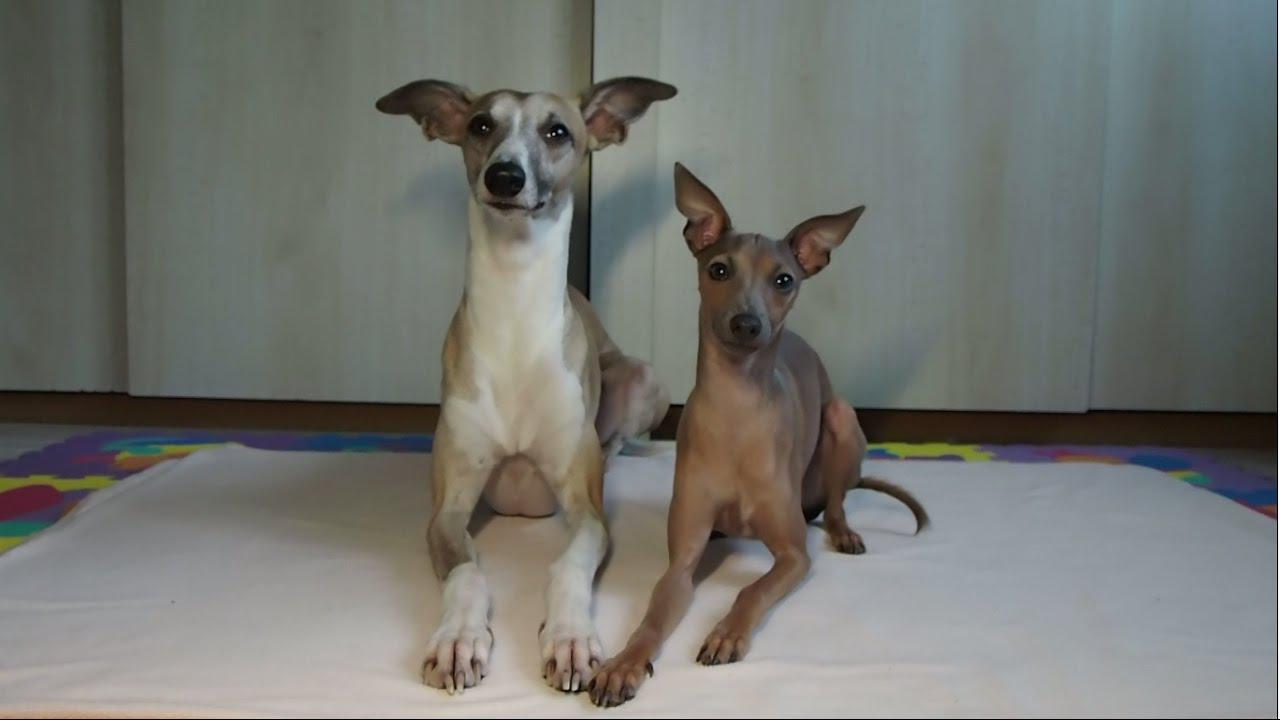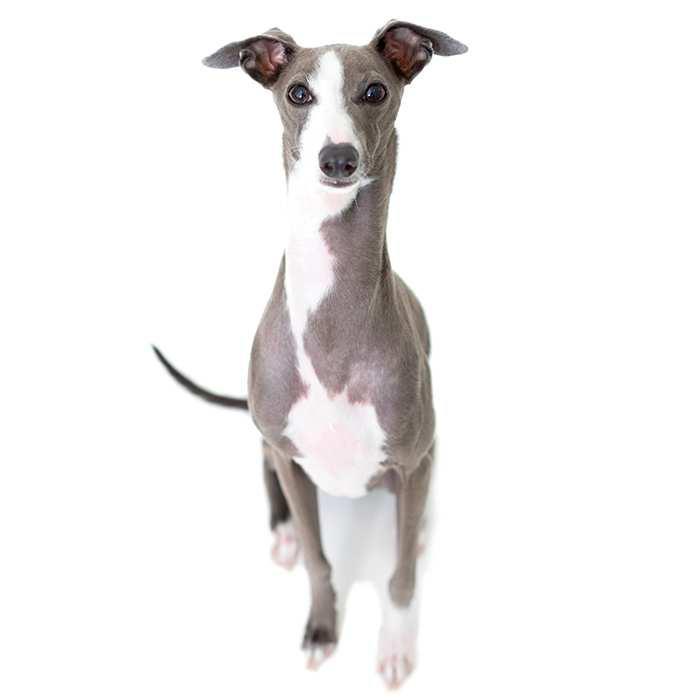The first image is the image on the left, the second image is the image on the right. Assess this claim about the two images: "There are 4 or more dogs, and at least two of them are touching.". Correct or not? Answer yes or no. No. The first image is the image on the left, the second image is the image on the right. Evaluate the accuracy of this statement regarding the images: "An image shows two similarly colored, non-standing dogs side-by-side.". Is it true? Answer yes or no. No. 